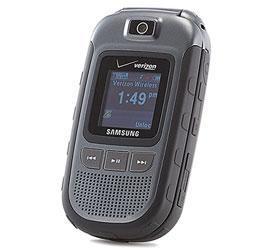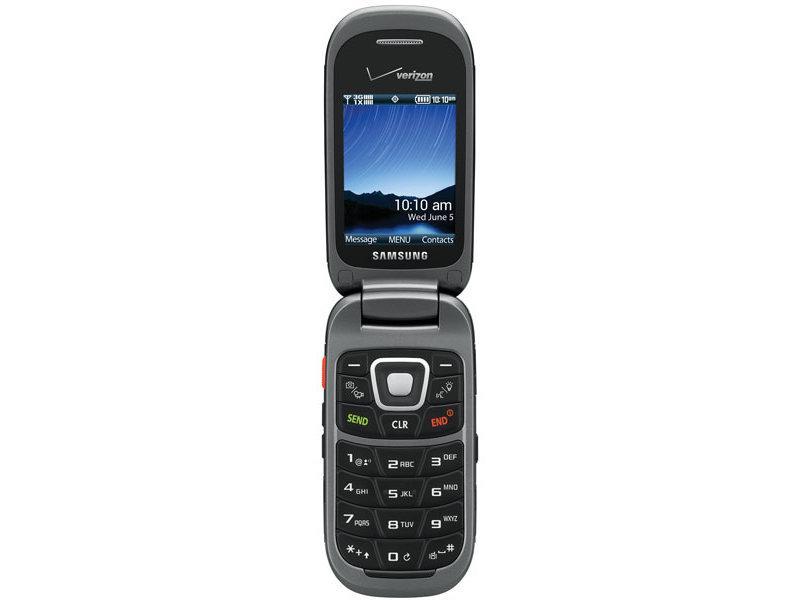The first image is the image on the left, the second image is the image on the right. Given the left and right images, does the statement "The left and right image contains the same number of flip phones." hold true? Answer yes or no. Yes. The first image is the image on the left, the second image is the image on the right. For the images displayed, is the sentence "Each image contains a single phone, and the phone in the right image has its top at least partially flipped open." factually correct? Answer yes or no. Yes. 